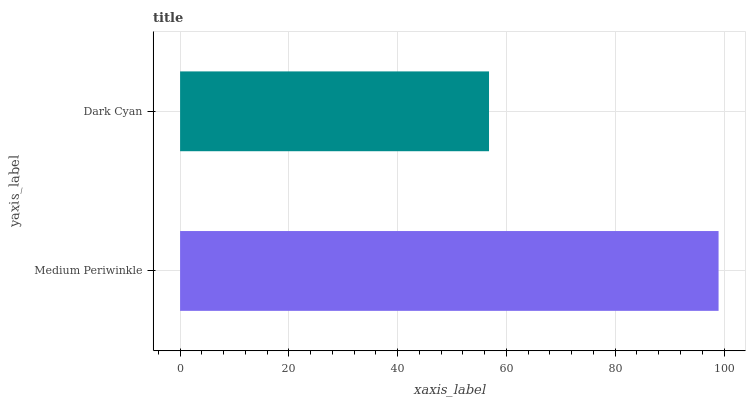Is Dark Cyan the minimum?
Answer yes or no. Yes. Is Medium Periwinkle the maximum?
Answer yes or no. Yes. Is Dark Cyan the maximum?
Answer yes or no. No. Is Medium Periwinkle greater than Dark Cyan?
Answer yes or no. Yes. Is Dark Cyan less than Medium Periwinkle?
Answer yes or no. Yes. Is Dark Cyan greater than Medium Periwinkle?
Answer yes or no. No. Is Medium Periwinkle less than Dark Cyan?
Answer yes or no. No. Is Medium Periwinkle the high median?
Answer yes or no. Yes. Is Dark Cyan the low median?
Answer yes or no. Yes. Is Dark Cyan the high median?
Answer yes or no. No. Is Medium Periwinkle the low median?
Answer yes or no. No. 